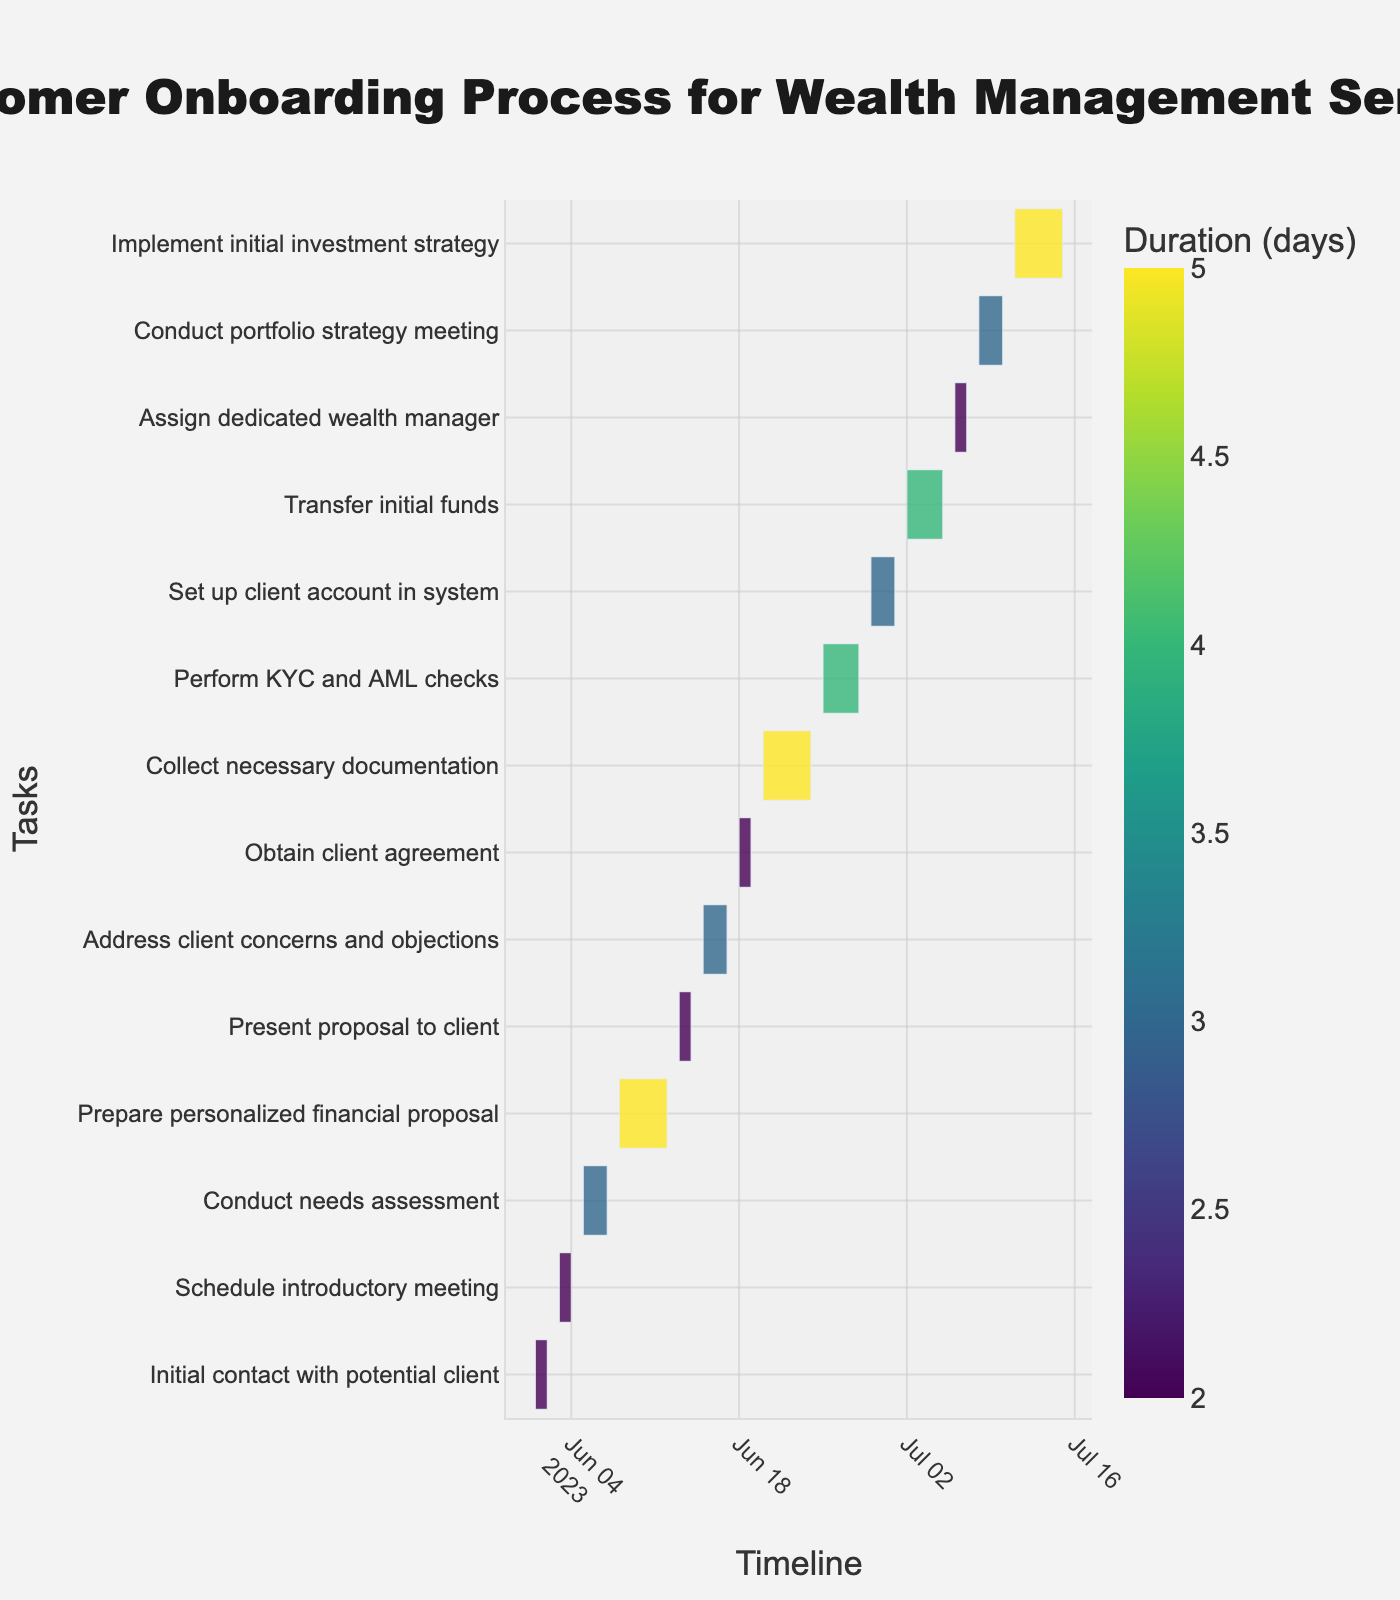What is the title of the Gantt chart? The title of the chart is displayed prominently at the top. It often summarizes the main focus of the figure. In this case, it mentions "Customer Onboarding Process for Wealth Management Service".
Answer: Customer Onboarding Process for Wealth Management Service How many tasks are listed in the Gantt chart? By counting the number of distinct tasks displayed along the y-axis of the chart, we can determine the total number of tasks. Each task corresponds to a step in the onboarding process.
Answer: 14 What task has the longest duration? By analyzing the length of the bars representing each task and referring to the colors indicating the "Duration (days)", we can identify that the task with the longest bar and the darkest shade will have the longest duration.
Answer: Prepare personalized financial proposal and Implement initial investment strategy What is the total duration (in days) to complete the onboarding process from initial contact to implementing the initial investment strategy? To get the total duration, sum up the duration of all tasks shown in "Duration (days)". Adding each duration: 2 + 2 + 3 + 5 + 2 + 3 + 2 + 5 + 4 + 3 + 4 + 2 + 3 + 5 = 41 days.
Answer: 41 days What is the average duration of all the tasks in the onboarding process? Calculate the average by summing the duration of all tasks and then dividing by the number of tasks. Sum of durations is 41 days. There are 14 tasks. Average duration = 41 / 14 ≈ 2.93 days.
Answer: 2.93 days Which task takes longer: "Conduct needs assessment" or "Conduct portfolio strategy meeting"? Compare the duration of these two tasks by checking their colored bars and seeing their indicated duration days. "Conduct needs assessment" is 3 days, and "Conduct portfolio strategy meeting" is also 3 days.
Answer: They take the same duration Which phase, "Collect necessary documentation" or "Perform KYC and AML checks", ends earlier? Look at the end date on the x-axis for both tasks. "Collect necessary documentation" ends on 2023-06-24, and "Perform KYC and AML checks" ends on 2023-06-28. Thus, "Collect necessary documentation" ends earlier.
Answer: Collect necessary documentation What is the color scale used to represent the duration of tasks in the Gantt chart? The color scale can be identified by observing the range of colors used to shade the duration bars. It is described in the explanation and by checking the legend associated with the chart.
Answer: Viridis How do the tasks "Prepare personalized financial proposal" and "Implement initial investment strategy" compare in terms of duration? Both tasks have their durations shown as colored bars. "Prepare personalized financial proposal" and "Implement initial investment strategy" both have the same duration of 5 days.
Answer: They have the same duration When does the "Transfer initial funds" start and end? By checking the start and end dates on the Gantt chart x-axis for the task "Transfer initial funds", we find it starts on 2023-07-02 and ends on 2023-07-05.
Answer: 2023-07-02 to 2023-07-05 